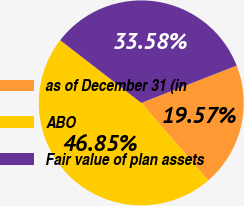Convert chart to OTSL. <chart><loc_0><loc_0><loc_500><loc_500><pie_chart><fcel>as of December 31 (in<fcel>ABO<fcel>Fair value of plan assets<nl><fcel>19.57%<fcel>46.85%<fcel>33.58%<nl></chart> 